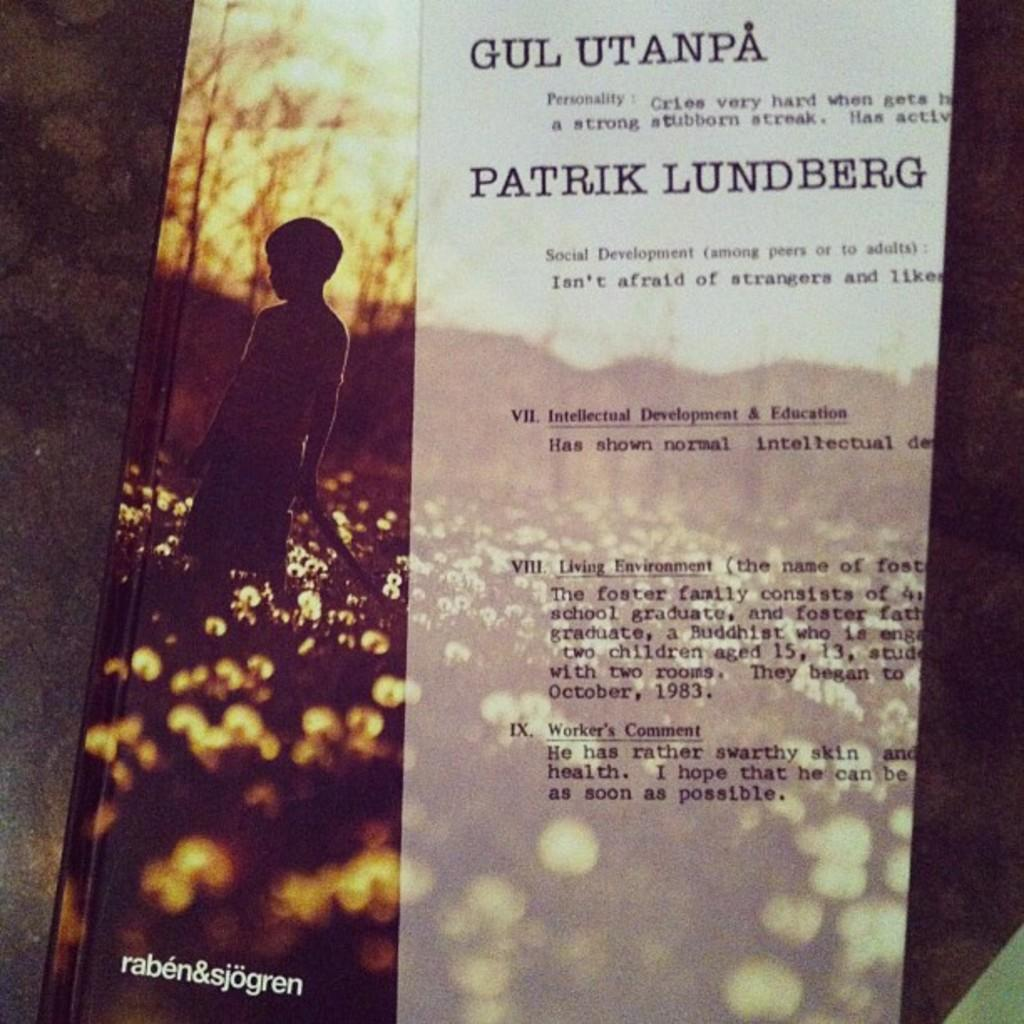<image>
Summarize the visual content of the image. A raben&sjogren book with a typewritten paper on top of it 